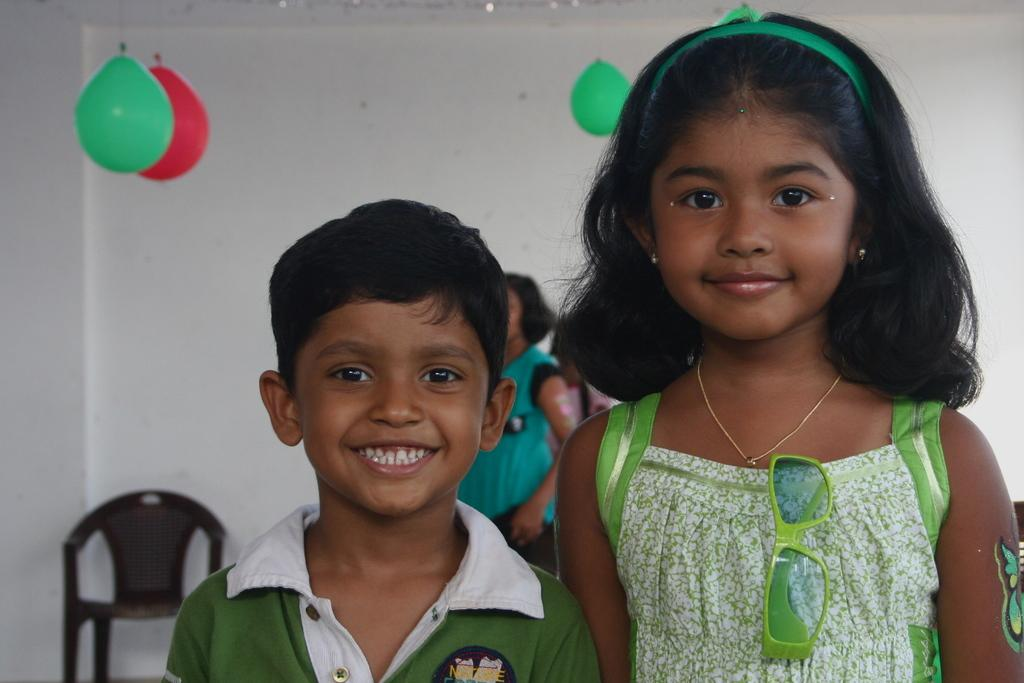How many people are in the image? There are two people in the image, a girl and a boy. What are the girl and the boy doing in the image? Both the girl and the boy are standing and smiling in the image. What can be seen in the background of the image? There is a chair, a woman, a wall, and a balloon in the background of the image. What type of ink is being used to write on the wall in the image? There is no indication in the image that anyone is writing on the wall, and therefore no ink can be observed. How many bananas are being held by the girl in the image? There are no bananas present in the image; the girl is not holding any. 